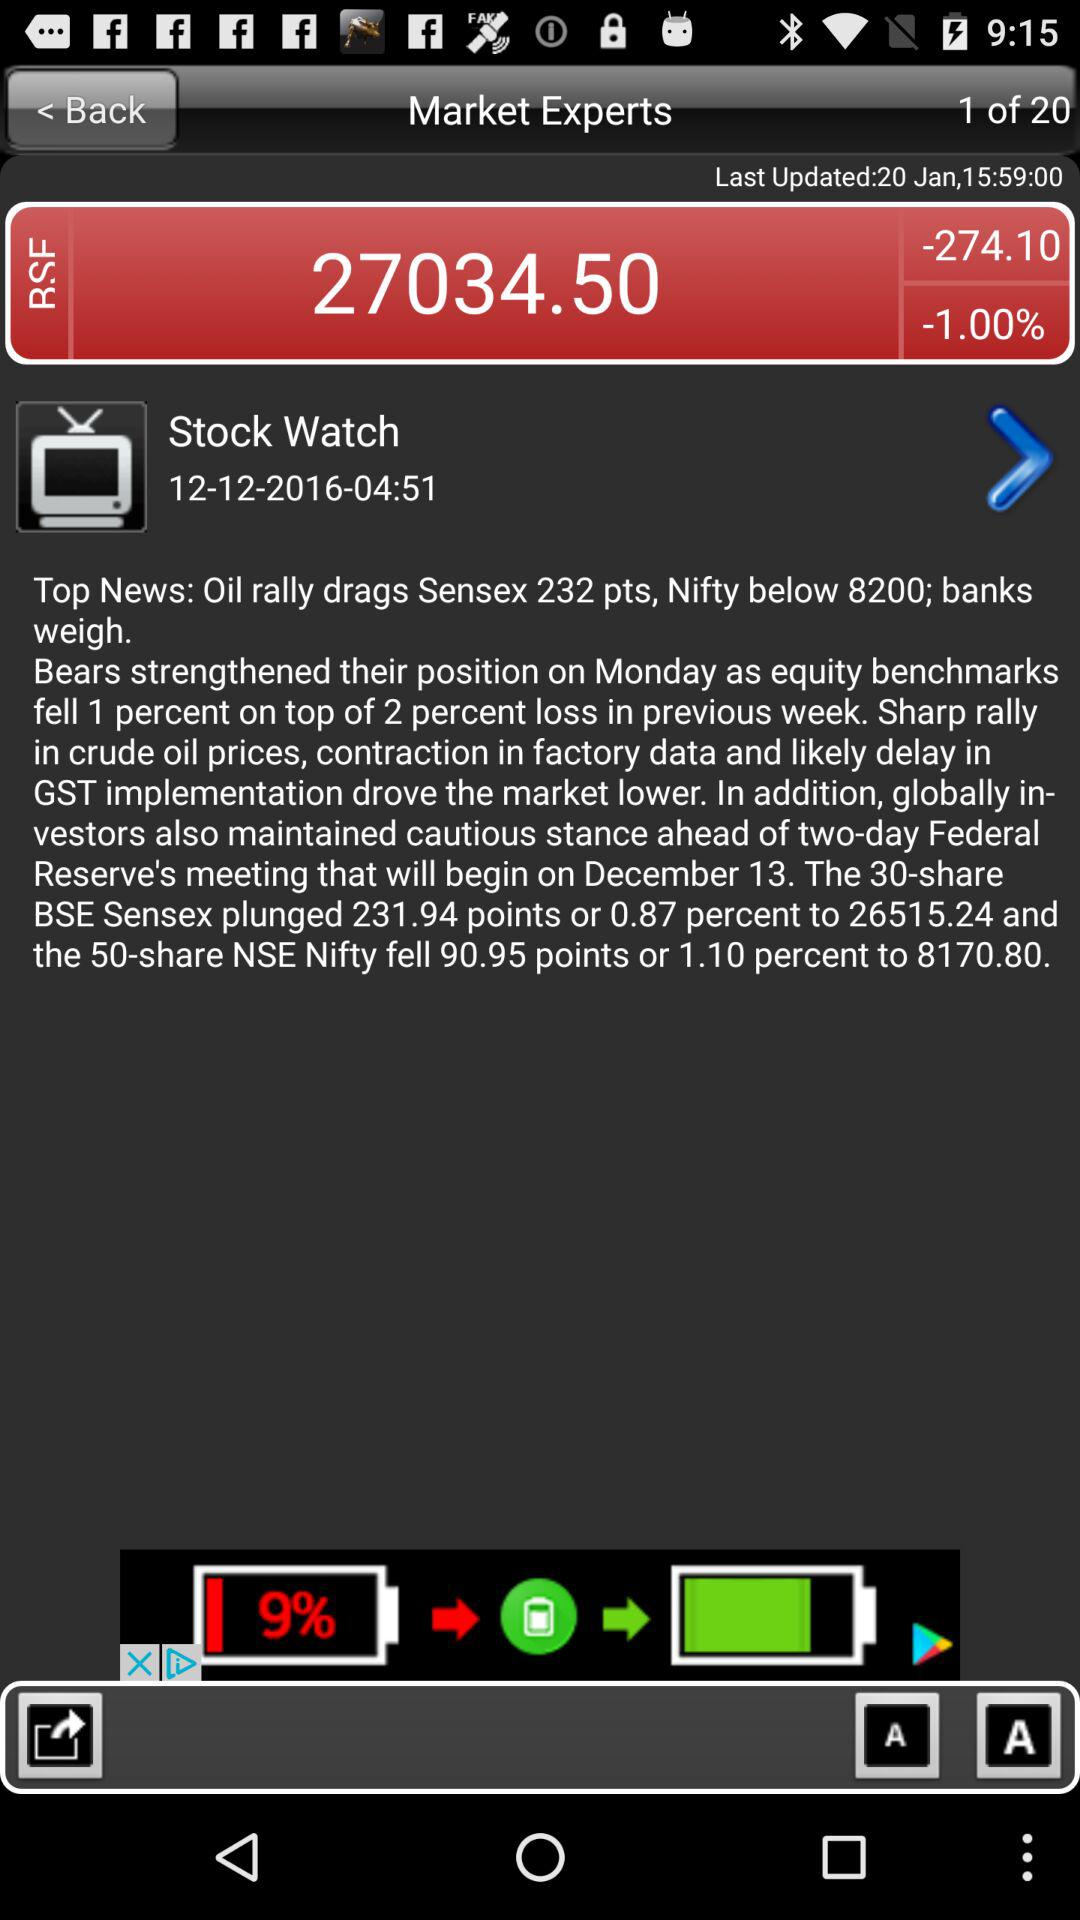What is the last updated date? The last updated date is January 20. 